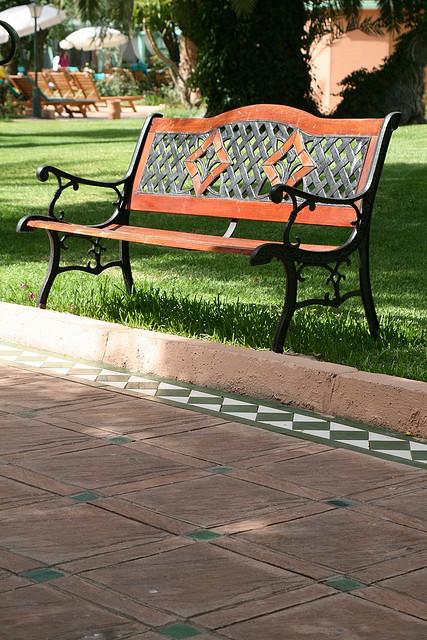Is there anyone sitting on the bench?
Answer briefly. No. What is the bench made of?
Short answer required. Wood and metal. What color is the bench?
Write a very short answer. Black and brown. Is there a trash can behind the bench?
Write a very short answer. No. 